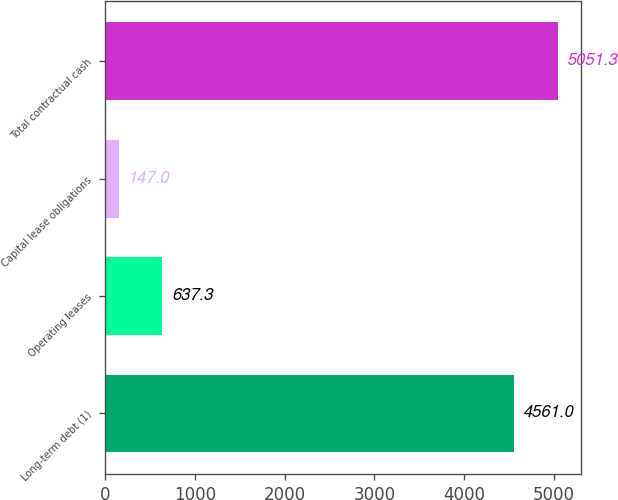Convert chart to OTSL. <chart><loc_0><loc_0><loc_500><loc_500><bar_chart><fcel>Long-term debt (1)<fcel>Operating leases<fcel>Capital lease obligations<fcel>Total contractual cash<nl><fcel>4561<fcel>637.3<fcel>147<fcel>5051.3<nl></chart> 